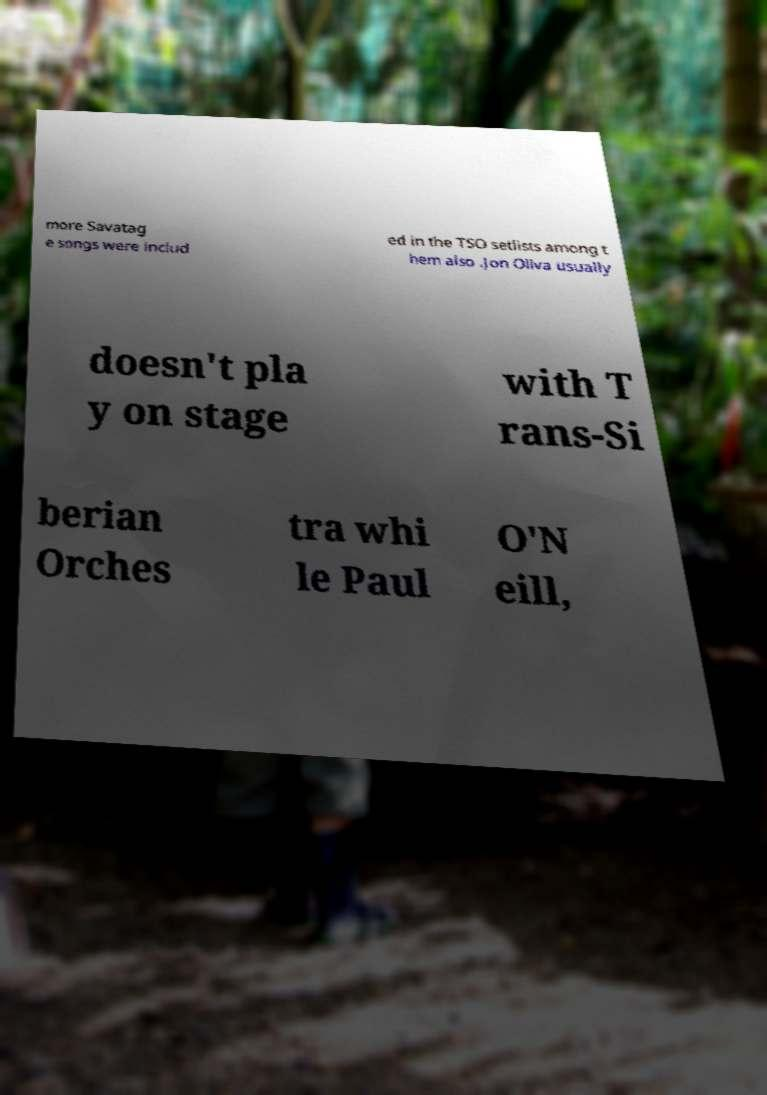Can you accurately transcribe the text from the provided image for me? more Savatag e songs were includ ed in the TSO setlists among t hem also .Jon Oliva usually doesn't pla y on stage with T rans-Si berian Orches tra whi le Paul O'N eill, 